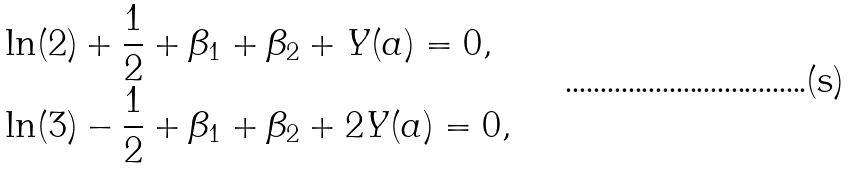Convert formula to latex. <formula><loc_0><loc_0><loc_500><loc_500>& \ln ( 2 ) + \frac { 1 } { 2 } + \beta _ { 1 } + \beta _ { 2 } + Y ( a ) = 0 , \\ & \ln ( 3 ) - \frac { 1 } { 2 } + \beta _ { 1 } + \beta _ { 2 } + 2 Y ( a ) = 0 ,</formula> 